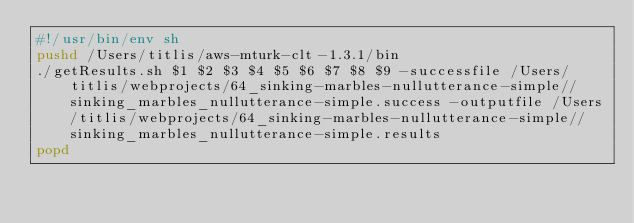Convert code to text. <code><loc_0><loc_0><loc_500><loc_500><_Bash_>#!/usr/bin/env sh
pushd /Users/titlis/aws-mturk-clt-1.3.1/bin
./getResults.sh $1 $2 $3 $4 $5 $6 $7 $8 $9 -successfile /Users/titlis/webprojects/64_sinking-marbles-nullutterance-simple//sinking_marbles_nullutterance-simple.success -outputfile /Users/titlis/webprojects/64_sinking-marbles-nullutterance-simple//sinking_marbles_nullutterance-simple.results
popd</code> 